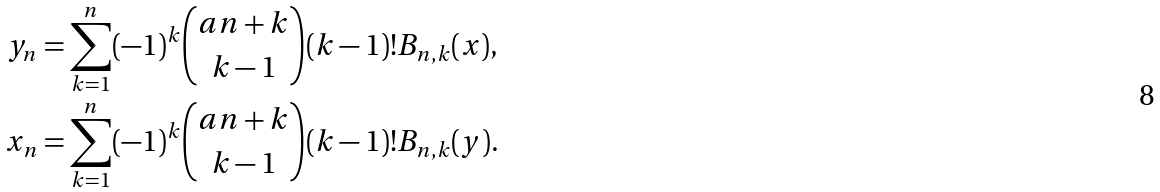Convert formula to latex. <formula><loc_0><loc_0><loc_500><loc_500>y _ { n } & = \sum _ { k = 1 } ^ { n } ( - 1 ) ^ { k } \binom { a n + k } { k - 1 } ( k - 1 ) ! B _ { n , k } ( x ) , \\ x _ { n } & = \sum _ { k = 1 } ^ { n } ( - 1 ) ^ { k } \binom { a n + k } { k - 1 } ( k - 1 ) ! B _ { n , k } ( y ) .</formula> 